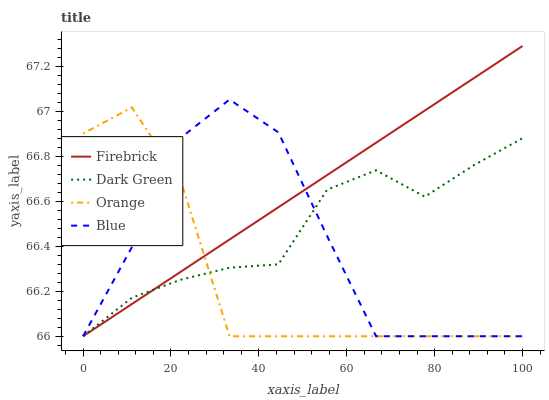Does Orange have the minimum area under the curve?
Answer yes or no. Yes. Does Firebrick have the maximum area under the curve?
Answer yes or no. Yes. Does Blue have the minimum area under the curve?
Answer yes or no. No. Does Blue have the maximum area under the curve?
Answer yes or no. No. Is Firebrick the smoothest?
Answer yes or no. Yes. Is Blue the roughest?
Answer yes or no. Yes. Is Blue the smoothest?
Answer yes or no. No. Is Firebrick the roughest?
Answer yes or no. No. Does Orange have the lowest value?
Answer yes or no. Yes. Does Firebrick have the highest value?
Answer yes or no. Yes. Does Blue have the highest value?
Answer yes or no. No. Does Blue intersect Dark Green?
Answer yes or no. Yes. Is Blue less than Dark Green?
Answer yes or no. No. Is Blue greater than Dark Green?
Answer yes or no. No. 